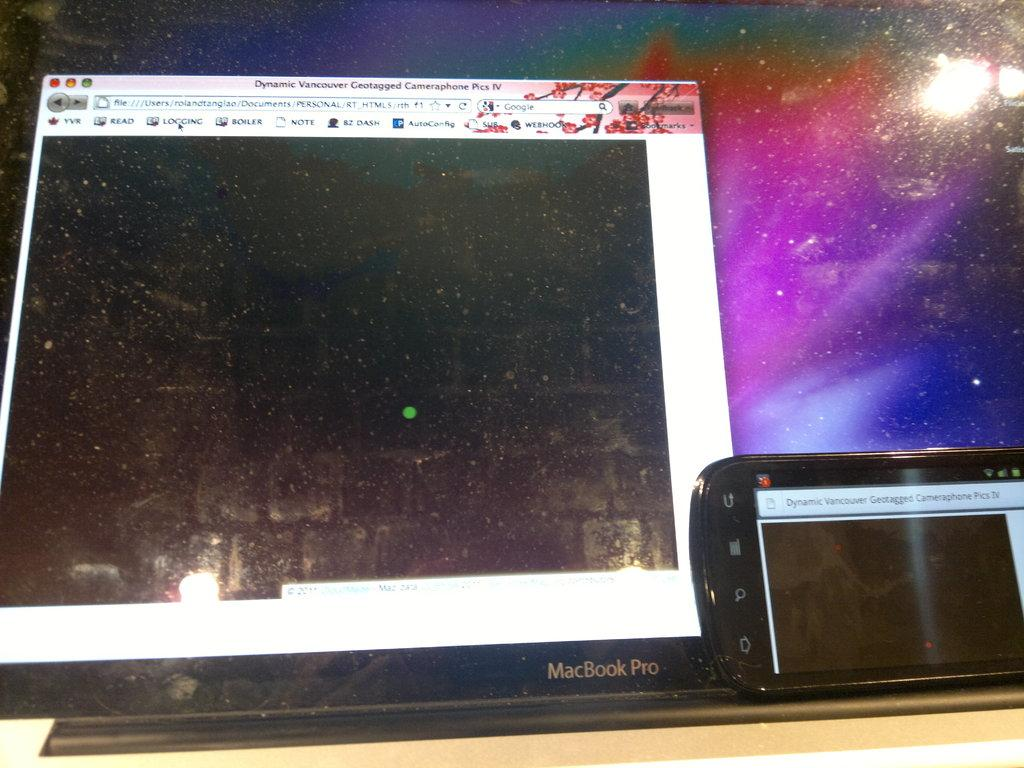Provide a one-sentence caption for the provided image. the computer pictured here is a MacBook Pro. 